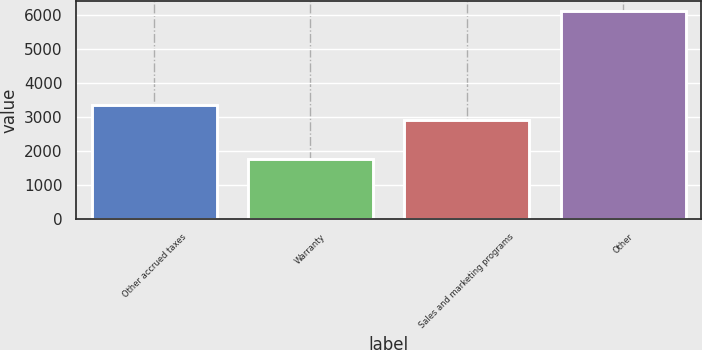Convert chart to OTSL. <chart><loc_0><loc_0><loc_500><loc_500><bar_chart><fcel>Other accrued taxes<fcel>Warranty<fcel>Sales and marketing programs<fcel>Other<nl><fcel>3366.4<fcel>1762<fcel>2930<fcel>6126<nl></chart> 